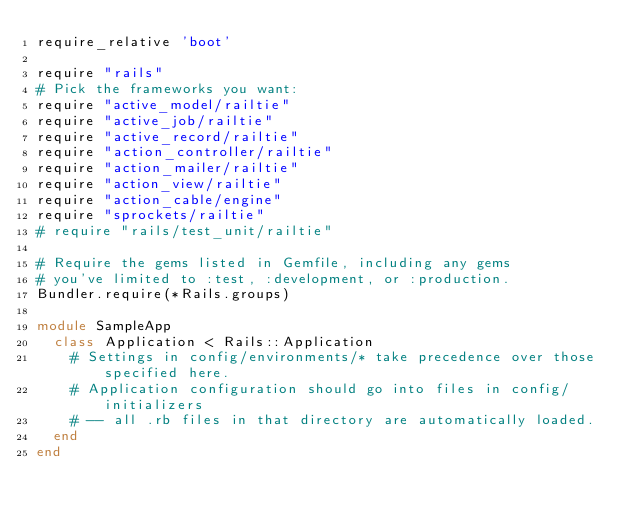<code> <loc_0><loc_0><loc_500><loc_500><_Ruby_>require_relative 'boot'

require "rails"
# Pick the frameworks you want:
require "active_model/railtie"
require "active_job/railtie"
require "active_record/railtie"
require "action_controller/railtie"
require "action_mailer/railtie"
require "action_view/railtie"
require "action_cable/engine"
require "sprockets/railtie"
# require "rails/test_unit/railtie"

# Require the gems listed in Gemfile, including any gems
# you've limited to :test, :development, or :production.
Bundler.require(*Rails.groups)

module SampleApp
  class Application < Rails::Application
    # Settings in config/environments/* take precedence over those specified here.
    # Application configuration should go into files in config/initializers
    # -- all .rb files in that directory are automatically loaded.
  end
end
</code> 